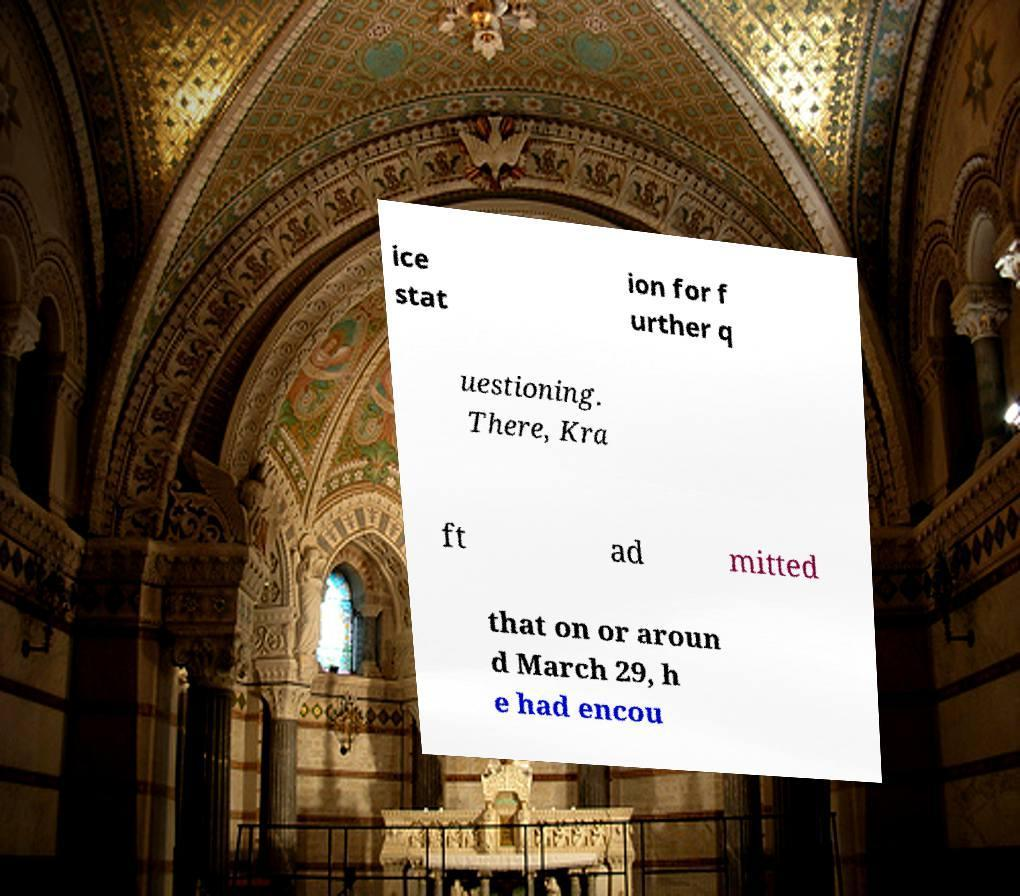For documentation purposes, I need the text within this image transcribed. Could you provide that? ice stat ion for f urther q uestioning. There, Kra ft ad mitted that on or aroun d March 29, h e had encou 